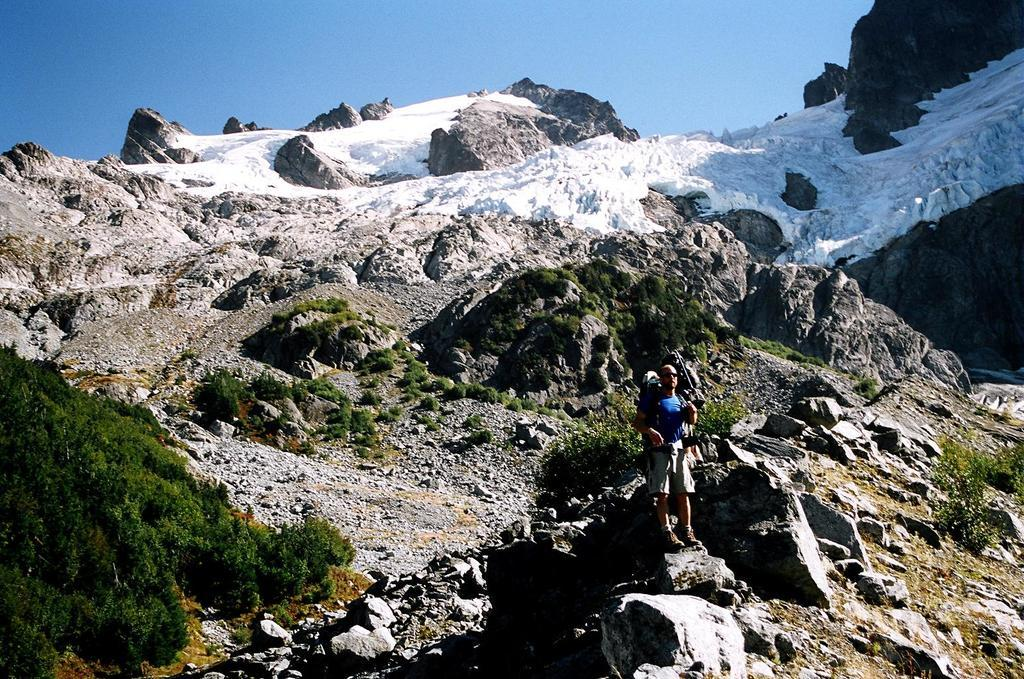What is the person in the image doing? There is a person standing on the mountain in the image. What else can be seen on the mountain besides the person? There are plants and snow on the mountain. What is visible at the top of the mountain? The sky is visible at the top of the mountain. What advice does the person on the mountain give to their daughter in the image? There is no daughter present in the image, and the person standing on the mountain is not giving any advice. 